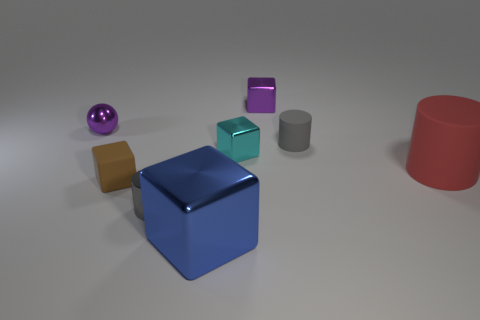What colors can be seen on the various objects displayed? The image showcases an array of colors including cyan, purple, gold, grey, and red on the various geometric objects. 